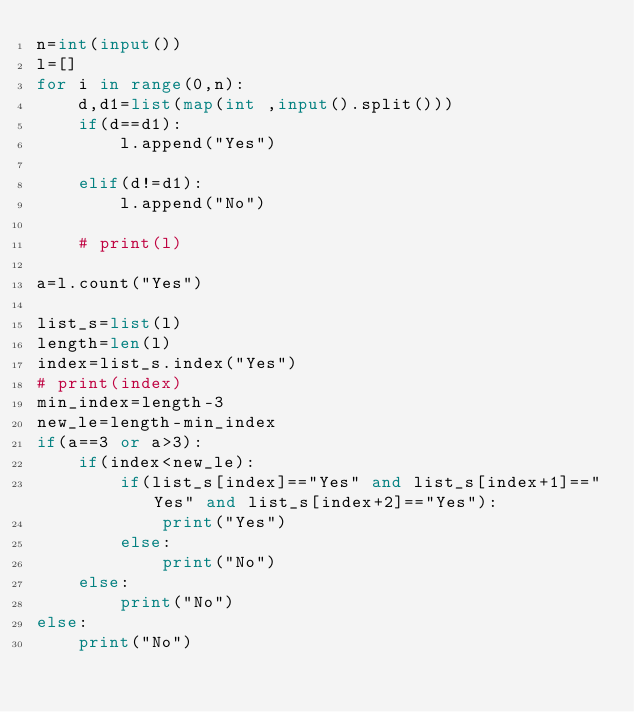<code> <loc_0><loc_0><loc_500><loc_500><_Python_>n=int(input())
l=[]
for i in range(0,n):
    d,d1=list(map(int ,input().split()))
    if(d==d1):
        l.append("Yes")
        
    elif(d!=d1):
        l.append("No")
        
    # print(l)
    
a=l.count("Yes")

list_s=list(l)
length=len(l)
index=list_s.index("Yes")
# print(index)
min_index=length-3
new_le=length-min_index
if(a==3 or a>3):
    if(index<new_le):
        if(list_s[index]=="Yes" and list_s[index+1]=="Yes" and list_s[index+2]=="Yes"):
            print("Yes")
        else:
            print("No")
    else:
        print("No")
else:
    print("No")</code> 